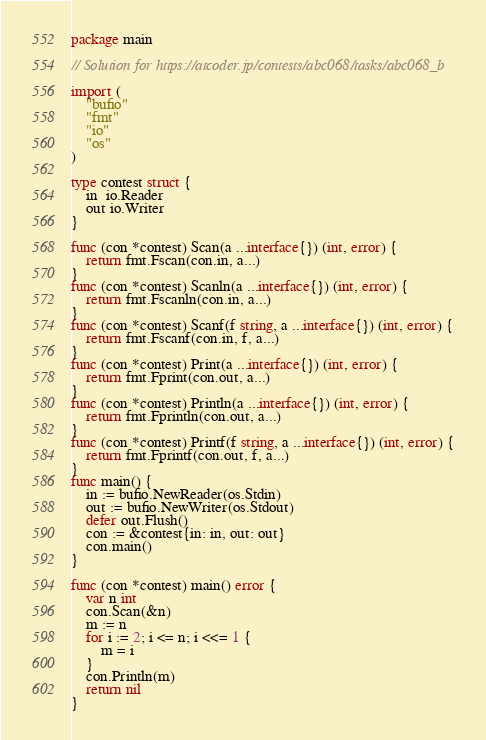<code> <loc_0><loc_0><loc_500><loc_500><_Go_>package main

// Solution for https://atcoder.jp/contests/abc068/tasks/abc068_b

import (
	"bufio"
	"fmt"
	"io"
	"os"
)

type contest struct {
	in  io.Reader
	out io.Writer
}

func (con *contest) Scan(a ...interface{}) (int, error) {
	return fmt.Fscan(con.in, a...)
}
func (con *contest) Scanln(a ...interface{}) (int, error) {
	return fmt.Fscanln(con.in, a...)
}
func (con *contest) Scanf(f string, a ...interface{}) (int, error) {
	return fmt.Fscanf(con.in, f, a...)
}
func (con *contest) Print(a ...interface{}) (int, error) {
	return fmt.Fprint(con.out, a...)
}
func (con *contest) Println(a ...interface{}) (int, error) {
	return fmt.Fprintln(con.out, a...)
}
func (con *contest) Printf(f string, a ...interface{}) (int, error) {
	return fmt.Fprintf(con.out, f, a...)
}
func main() {
	in := bufio.NewReader(os.Stdin)
	out := bufio.NewWriter(os.Stdout)
	defer out.Flush()
	con := &contest{in: in, out: out}
	con.main()
}

func (con *contest) main() error {
	var n int
	con.Scan(&n)
	m := n
	for i := 2; i <= n; i <<= 1 {
		m = i
	}
	con.Println(m)
	return nil
}
</code> 